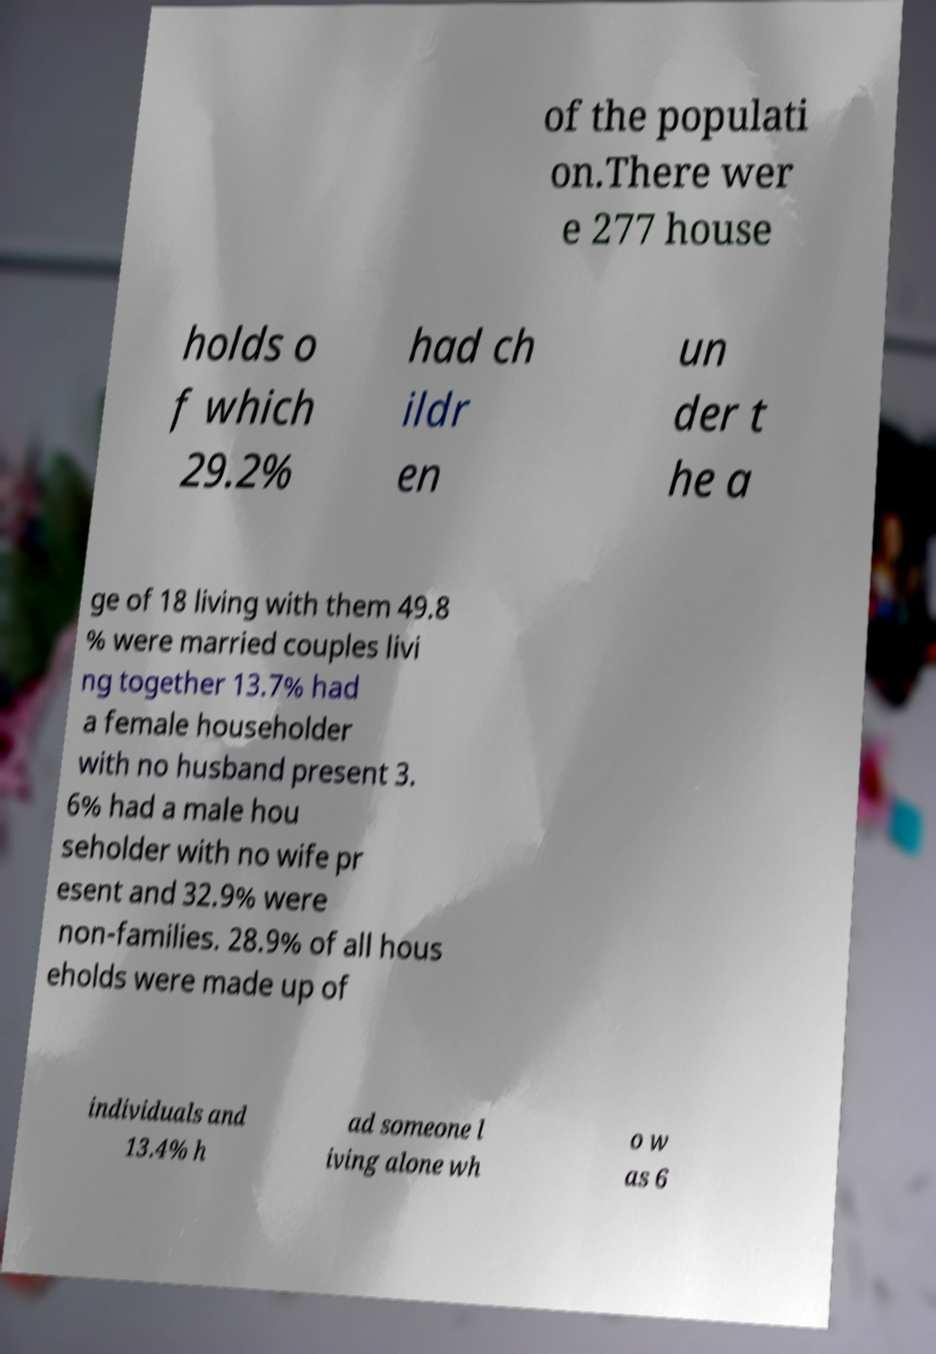What messages or text are displayed in this image? I need them in a readable, typed format. of the populati on.There wer e 277 house holds o f which 29.2% had ch ildr en un der t he a ge of 18 living with them 49.8 % were married couples livi ng together 13.7% had a female householder with no husband present 3. 6% had a male hou seholder with no wife pr esent and 32.9% were non-families. 28.9% of all hous eholds were made up of individuals and 13.4% h ad someone l iving alone wh o w as 6 